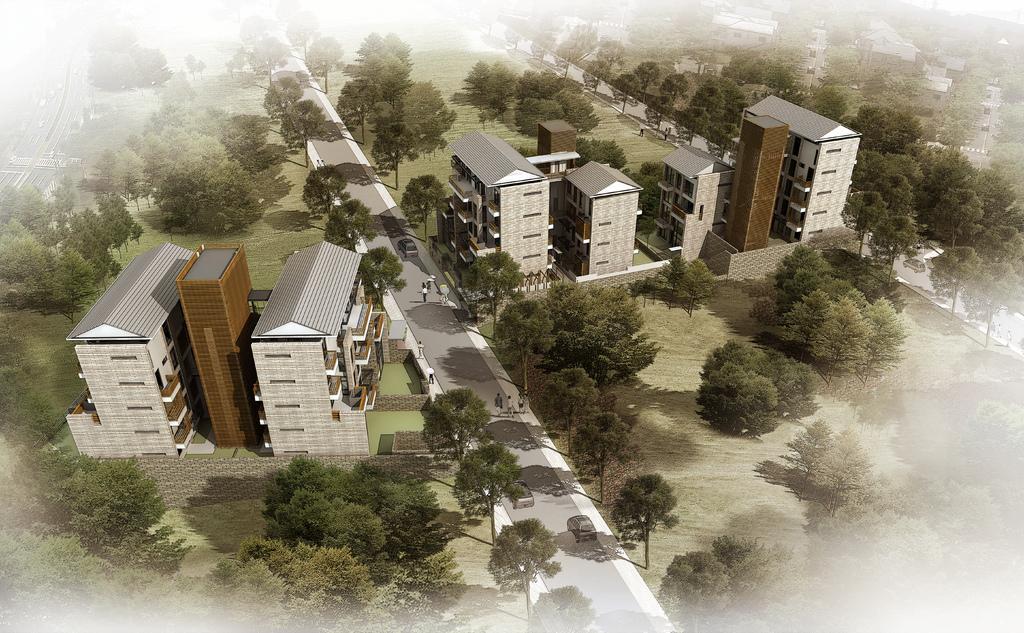Could you give a brief overview of what you see in this image? In this image we can see an aerial view of buildings, trees, roads and we can see cars and people walking on the road. 